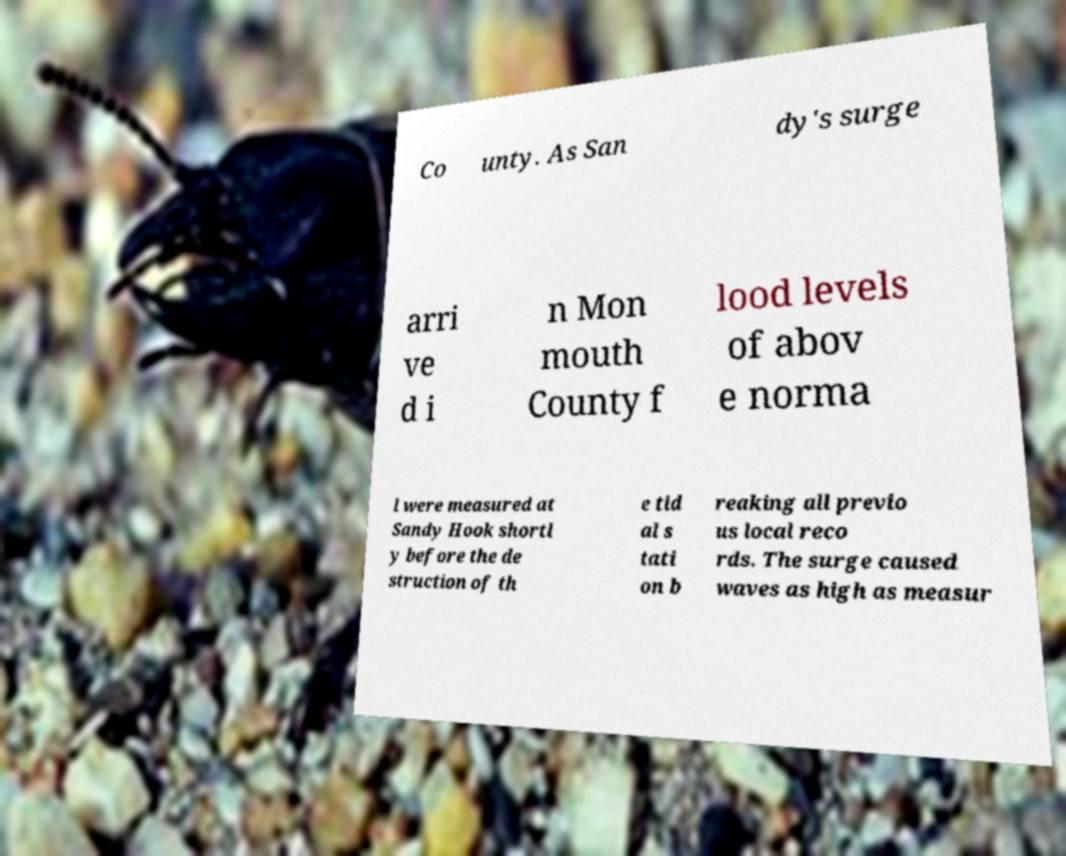Can you read and provide the text displayed in the image?This photo seems to have some interesting text. Can you extract and type it out for me? Co unty. As San dy's surge arri ve d i n Mon mouth County f lood levels of abov e norma l were measured at Sandy Hook shortl y before the de struction of th e tid al s tati on b reaking all previo us local reco rds. The surge caused waves as high as measur 